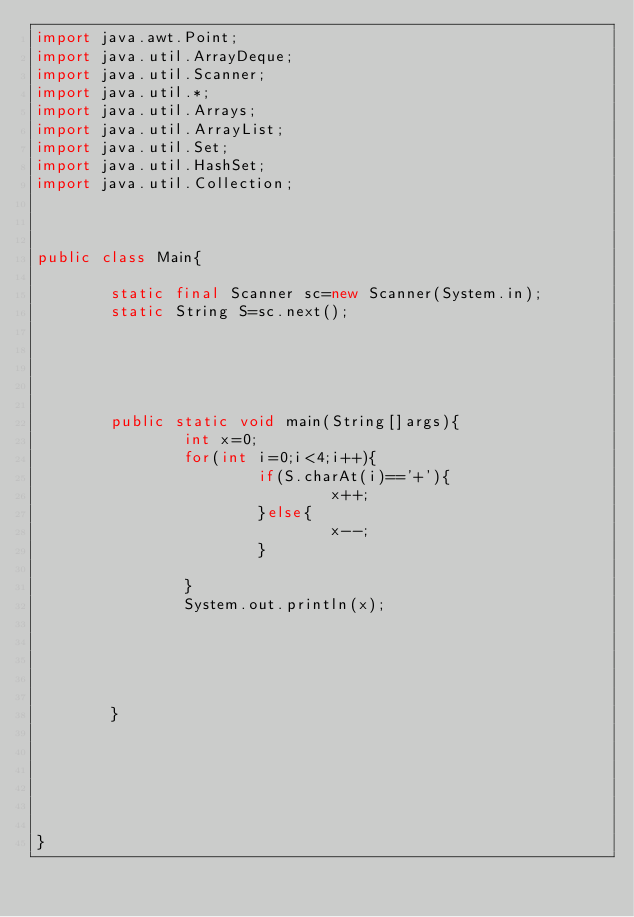<code> <loc_0><loc_0><loc_500><loc_500><_Java_>import java.awt.Point;
import java.util.ArrayDeque;
import java.util.Scanner;
import java.util.*;
import java.util.Arrays;
import java.util.ArrayList;
import java.util.Set;
import java.util.HashSet;
import java.util.Collection;


 
public class Main{
	
        static final Scanner sc=new Scanner(System.in);
        static String S=sc.next();
        
        
        
        
        
        public static void main(String[]args){
                int x=0;
                for(int i=0;i<4;i++){
                        if(S.charAt(i)=='+'){
                                x++;
                        }else{
                                x--;
                        }

                }
                System.out.println(x);


                
                

        }
        
        
        

		
	
}
</code> 